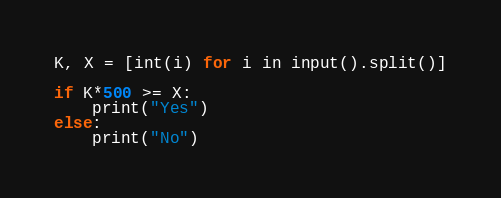<code> <loc_0><loc_0><loc_500><loc_500><_Python_>K, X = [int(i) for i in input().split()]

if K*500 >= X:
    print("Yes")
else:
    print("No")
</code> 